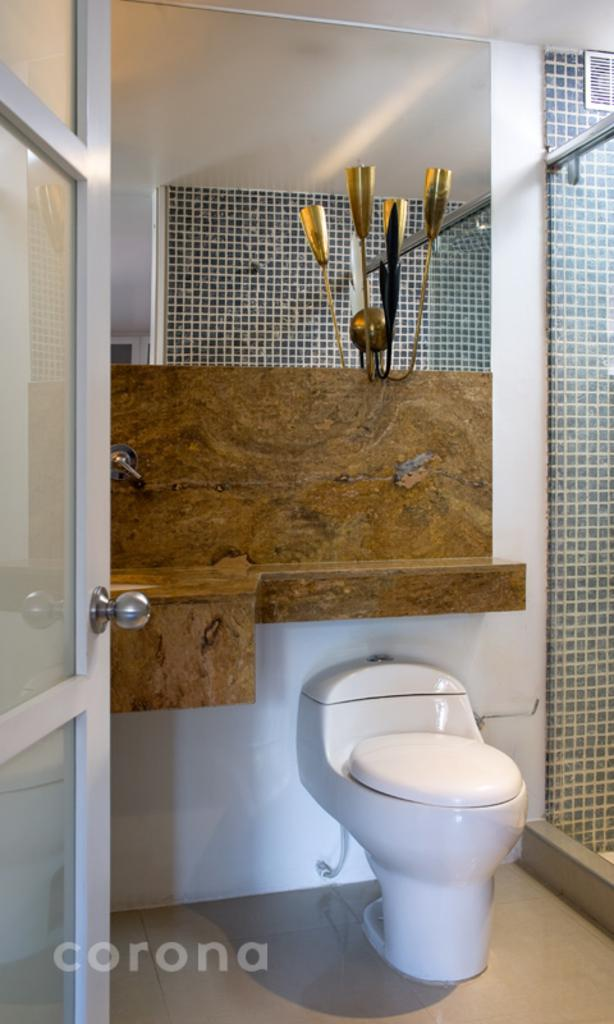What type of fixture is present in the image? There is a toilet seat in the image. What is another fixture that can be seen in the image? There is a mirror in the image. What is the third fixture in the image? There is a wash basin in the image. Where is the wash basin located in the image? The wash basin is on the left side of the image. What other feature can be seen in the image? There is a glass door in the image. Is there any text or marking visible in the image? Yes, there is a watermark at the bottom left corner of the image. What type of dinner is being served in the image? There is no dinner being served in the image; it features bathroom fixtures and a glass door. Can you tell me who the parent is in the image? There are no people present in the image, so it is not possible to identify a parent. 